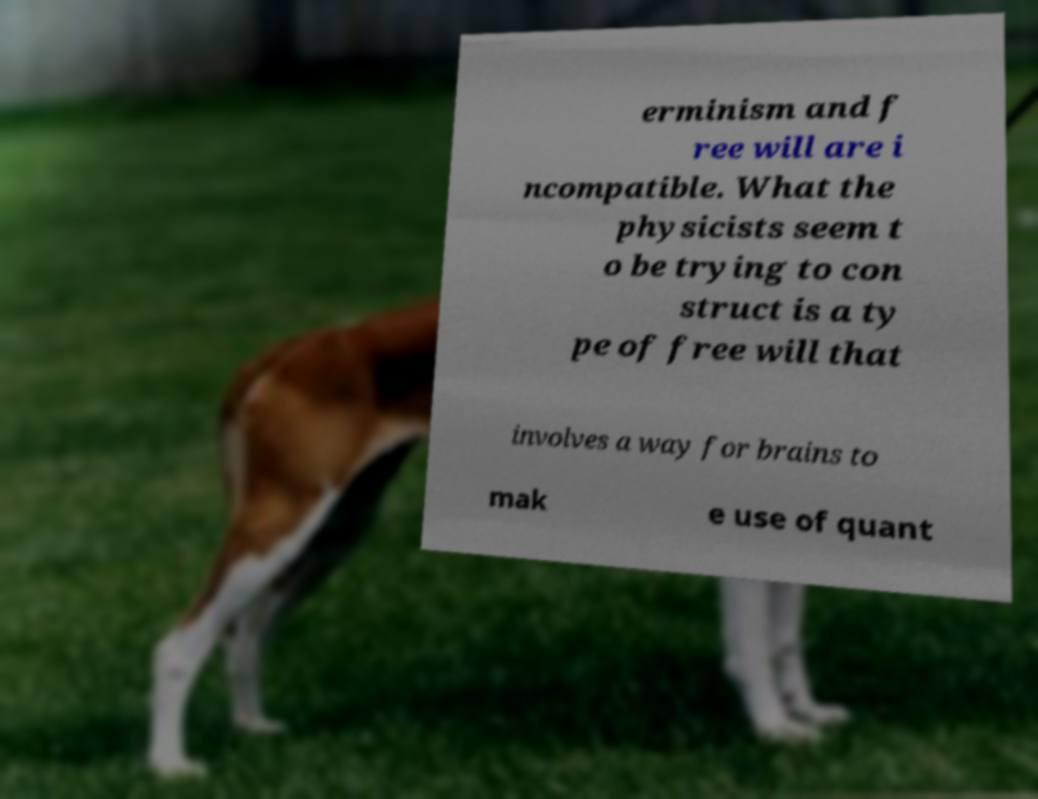Could you assist in decoding the text presented in this image and type it out clearly? erminism and f ree will are i ncompatible. What the physicists seem t o be trying to con struct is a ty pe of free will that involves a way for brains to mak e use of quant 